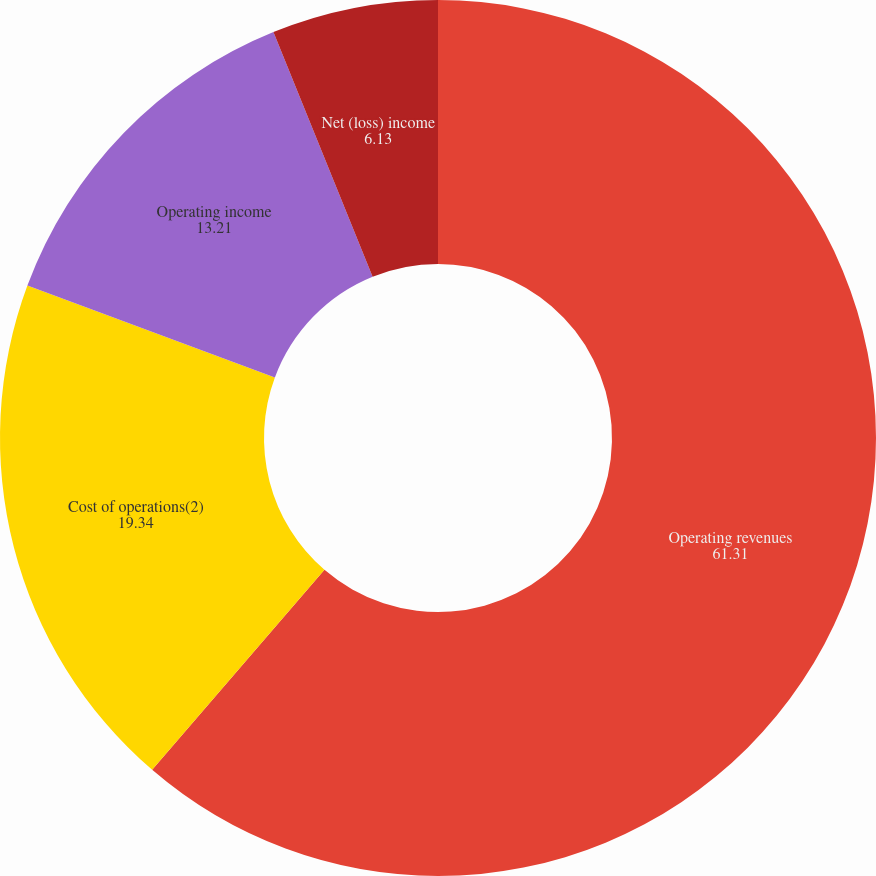Convert chart. <chart><loc_0><loc_0><loc_500><loc_500><pie_chart><fcel>Operating revenues<fcel>Cost of operations(2)<fcel>Operating income<fcel>Net (loss) income<fcel>Basic and diluted net (loss)<nl><fcel>61.31%<fcel>19.34%<fcel>13.21%<fcel>6.13%<fcel>0.0%<nl></chart> 